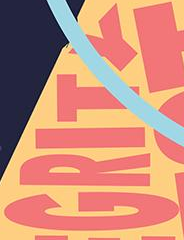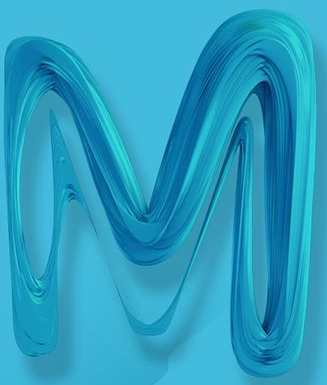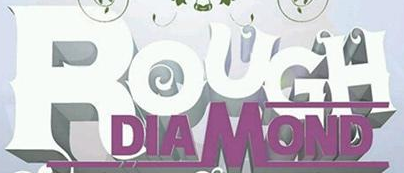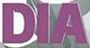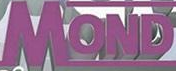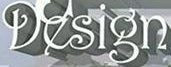Read the text content from these images in order, separated by a semicolon. GRITY; M; ROUGH; DIA; MOND; Design 